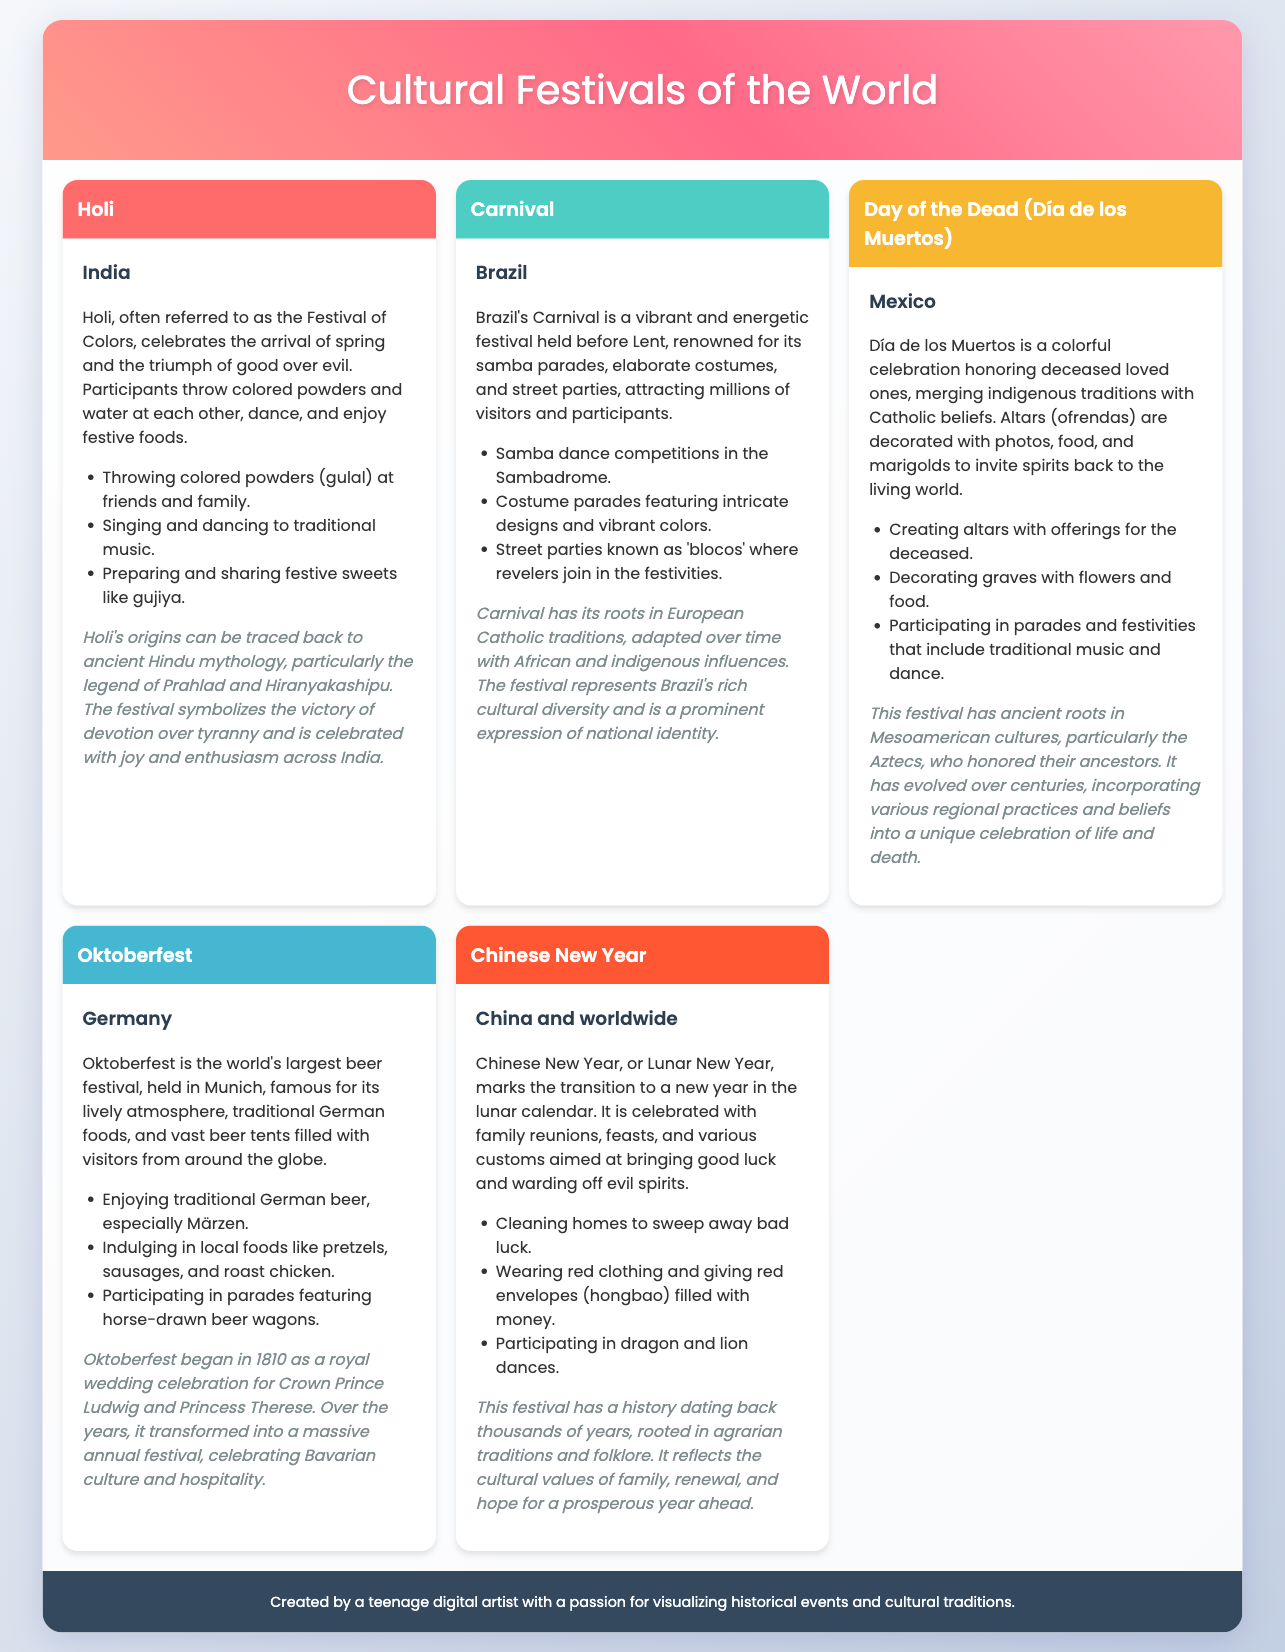What is the first festival listed? The first festival mentioned in the document is "Holi."
Answer: Holi Which country celebrates the Carnival? The document states that Carnival is celebrated in Brazil.
Answer: Brazil What type of dance is featured in the Chinese New Year celebrations? The document mentions dragon and lion dances as part of the customs.
Answer: dancing How did Oktoberfest begin? The document indicates that Oktoberfest began as a royal wedding celebration.
Answer: royal wedding celebration What is the primary color worn during Chinese New Year? The document states that red clothing is commonly worn during the celebration.
Answer: red What does Día de los Muertos honor? The festival honors deceased loved ones.
Answer: deceased loved ones Which festival is described as the world's largest beer festival? The document identifies Oktoberfest as the world's largest beer festival.
Answer: Oktoberfest What traditional food is associated with Holi? The document mentions "gujiya" as a festive sweet prepared and shared.
Answer: gujiya 